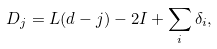Convert formula to latex. <formula><loc_0><loc_0><loc_500><loc_500>D _ { j } = L ( d - j ) - 2 I + \sum _ { i } \delta _ { i } ,</formula> 